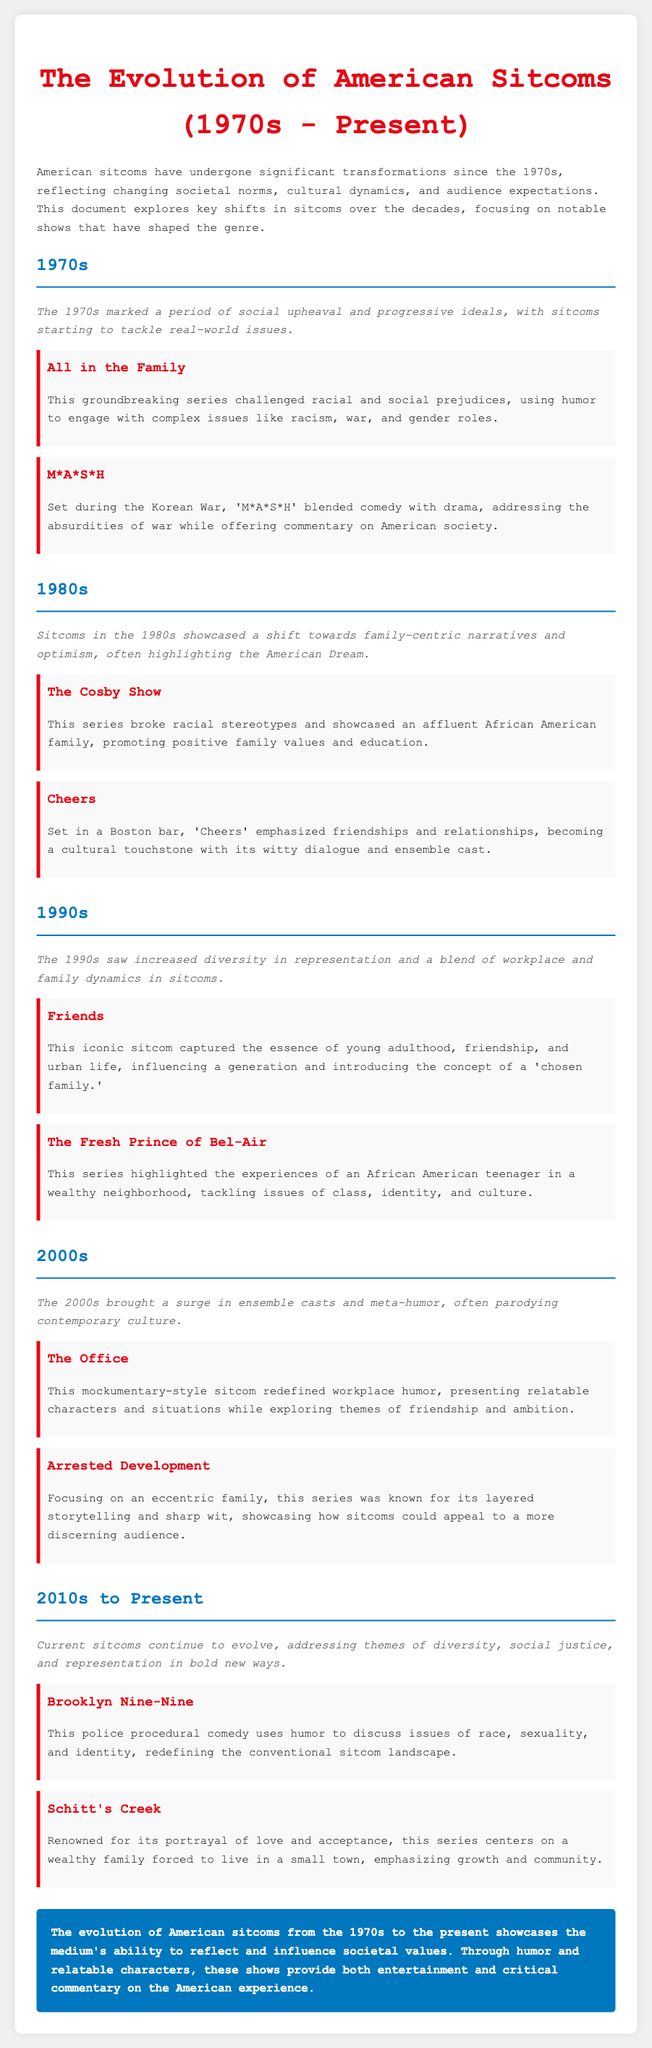what decade marked the beginning of social upheaval in sitcoms? The document states that the 1970s marked a period of social upheaval and progressive ideals in sitcoms.
Answer: 1970s which sitcom tackled issues like racism and gender roles? The document highlights "All in the Family" as a groundbreaking series that challenged these issues through humor.
Answer: All in the Family what is a key theme of the 1990s sitcoms? The document notes that the 1990s saw increased diversity in representation and a blend of workplace and family dynamics in sitcoms.
Answer: Increased diversity which sitcom is known for its portrayal of a wealthy family in a small town? According to the document, "Schitt's Creek" centers on this theme of a wealthy family forced to live in a small town.
Answer: Schitt's Creek what cultural shift occurred in American sitcoms during the 1980s? The document discusses that the 1980s shifted towards family-centric narratives and optimism, often highlighting the American Dream.
Answer: Family-centric narratives which show, set in a Boston bar, emphasized friendships? The document identifies "Cheers" as the sitcom that emphasized relationships and friendships within that setting.
Answer: Cheers how did "The Office" redefine workplace humor? The document describes "The Office" as using a mockumentary style to present relatable characters and situations in the workplace.
Answer: Mockumentary style what main issues does "Brooklyn Nine-Nine" address through humor? The document states that this show uses humor to discuss issues of race, sexuality, and identity.
Answer: Race, sexuality, and identity 